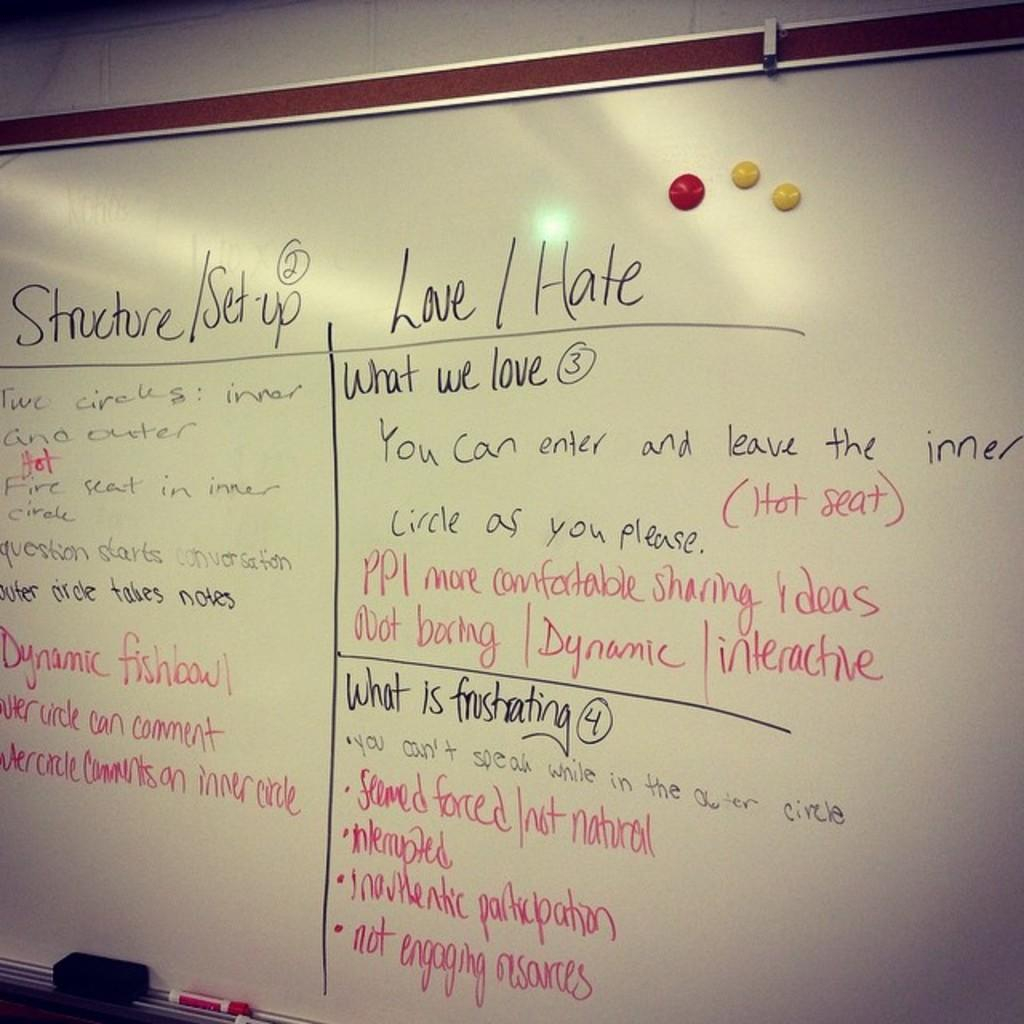<image>
Render a clear and concise summary of the photo. White board in a room which says "Love and Hate" on the top. 